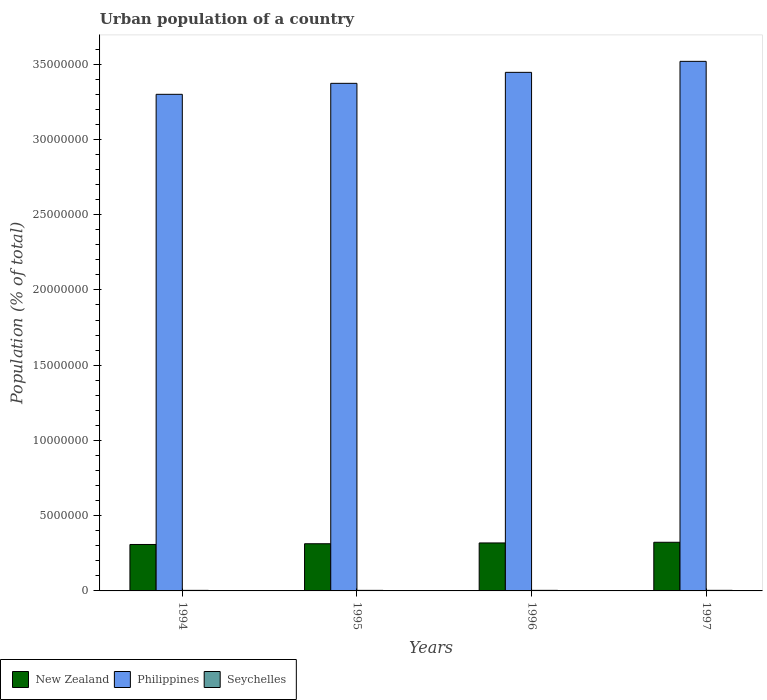How many different coloured bars are there?
Offer a terse response. 3. How many groups of bars are there?
Your answer should be very brief. 4. Are the number of bars per tick equal to the number of legend labels?
Ensure brevity in your answer.  Yes. How many bars are there on the 1st tick from the left?
Make the answer very short. 3. How many bars are there on the 2nd tick from the right?
Make the answer very short. 3. What is the label of the 2nd group of bars from the left?
Offer a very short reply. 1995. What is the urban population in Philippines in 1995?
Offer a terse response. 3.37e+07. Across all years, what is the maximum urban population in Seychelles?
Provide a short and direct response. 3.84e+04. Across all years, what is the minimum urban population in Seychelles?
Your answer should be very brief. 3.65e+04. In which year was the urban population in Philippines maximum?
Offer a terse response. 1997. What is the total urban population in Seychelles in the graph?
Your answer should be very brief. 1.50e+05. What is the difference between the urban population in Philippines in 1994 and that in 1995?
Make the answer very short. -7.30e+05. What is the difference between the urban population in Seychelles in 1997 and the urban population in New Zealand in 1996?
Your answer should be compact. -3.15e+06. What is the average urban population in New Zealand per year?
Provide a succinct answer. 3.16e+06. In the year 1997, what is the difference between the urban population in New Zealand and urban population in Philippines?
Provide a succinct answer. -3.20e+07. What is the ratio of the urban population in Philippines in 1996 to that in 1997?
Ensure brevity in your answer.  0.98. Is the difference between the urban population in New Zealand in 1995 and 1996 greater than the difference between the urban population in Philippines in 1995 and 1996?
Provide a short and direct response. Yes. What is the difference between the highest and the second highest urban population in Seychelles?
Your answer should be compact. 530. What is the difference between the highest and the lowest urban population in Philippines?
Your answer should be very brief. 2.19e+06. Is the sum of the urban population in Philippines in 1996 and 1997 greater than the maximum urban population in New Zealand across all years?
Keep it short and to the point. Yes. What does the 2nd bar from the left in 1996 represents?
Make the answer very short. Philippines. What does the 1st bar from the right in 1996 represents?
Offer a very short reply. Seychelles. Are the values on the major ticks of Y-axis written in scientific E-notation?
Offer a terse response. No. How many legend labels are there?
Keep it short and to the point. 3. How are the legend labels stacked?
Ensure brevity in your answer.  Horizontal. What is the title of the graph?
Keep it short and to the point. Urban population of a country. Does "Ireland" appear as one of the legend labels in the graph?
Your response must be concise. No. What is the label or title of the Y-axis?
Provide a succinct answer. Population (% of total). What is the Population (% of total) in New Zealand in 1994?
Make the answer very short. 3.09e+06. What is the Population (% of total) in Philippines in 1994?
Your answer should be compact. 3.30e+07. What is the Population (% of total) in Seychelles in 1994?
Your answer should be very brief. 3.65e+04. What is the Population (% of total) of New Zealand in 1995?
Your response must be concise. 3.13e+06. What is the Population (% of total) in Philippines in 1995?
Keep it short and to the point. 3.37e+07. What is the Population (% of total) in Seychelles in 1995?
Your answer should be very brief. 3.73e+04. What is the Population (% of total) of New Zealand in 1996?
Offer a terse response. 3.19e+06. What is the Population (% of total) of Philippines in 1996?
Give a very brief answer. 3.45e+07. What is the Population (% of total) of Seychelles in 1996?
Give a very brief answer. 3.79e+04. What is the Population (% of total) in New Zealand in 1997?
Your response must be concise. 3.23e+06. What is the Population (% of total) of Philippines in 1997?
Your answer should be very brief. 3.52e+07. What is the Population (% of total) in Seychelles in 1997?
Your response must be concise. 3.84e+04. Across all years, what is the maximum Population (% of total) of New Zealand?
Your answer should be compact. 3.23e+06. Across all years, what is the maximum Population (% of total) in Philippines?
Give a very brief answer. 3.52e+07. Across all years, what is the maximum Population (% of total) in Seychelles?
Make the answer very short. 3.84e+04. Across all years, what is the minimum Population (% of total) of New Zealand?
Provide a short and direct response. 3.09e+06. Across all years, what is the minimum Population (% of total) of Philippines?
Ensure brevity in your answer.  3.30e+07. Across all years, what is the minimum Population (% of total) of Seychelles?
Provide a succinct answer. 3.65e+04. What is the total Population (% of total) of New Zealand in the graph?
Make the answer very short. 1.26e+07. What is the total Population (% of total) of Philippines in the graph?
Keep it short and to the point. 1.36e+08. What is the total Population (% of total) in Seychelles in the graph?
Your response must be concise. 1.50e+05. What is the difference between the Population (% of total) in New Zealand in 1994 and that in 1995?
Provide a short and direct response. -4.92e+04. What is the difference between the Population (% of total) of Philippines in 1994 and that in 1995?
Provide a succinct answer. -7.30e+05. What is the difference between the Population (% of total) in Seychelles in 1994 and that in 1995?
Ensure brevity in your answer.  -742. What is the difference between the Population (% of total) of New Zealand in 1994 and that in 1996?
Offer a very short reply. -1.02e+05. What is the difference between the Population (% of total) of Philippines in 1994 and that in 1996?
Keep it short and to the point. -1.46e+06. What is the difference between the Population (% of total) of Seychelles in 1994 and that in 1996?
Your answer should be very brief. -1364. What is the difference between the Population (% of total) in New Zealand in 1994 and that in 1997?
Your answer should be very brief. -1.47e+05. What is the difference between the Population (% of total) of Philippines in 1994 and that in 1997?
Provide a short and direct response. -2.19e+06. What is the difference between the Population (% of total) in Seychelles in 1994 and that in 1997?
Ensure brevity in your answer.  -1894. What is the difference between the Population (% of total) of New Zealand in 1995 and that in 1996?
Provide a succinct answer. -5.33e+04. What is the difference between the Population (% of total) in Philippines in 1995 and that in 1996?
Make the answer very short. -7.31e+05. What is the difference between the Population (% of total) of Seychelles in 1995 and that in 1996?
Your response must be concise. -622. What is the difference between the Population (% of total) in New Zealand in 1995 and that in 1997?
Your answer should be compact. -9.78e+04. What is the difference between the Population (% of total) in Philippines in 1995 and that in 1997?
Your answer should be very brief. -1.46e+06. What is the difference between the Population (% of total) in Seychelles in 1995 and that in 1997?
Your response must be concise. -1152. What is the difference between the Population (% of total) in New Zealand in 1996 and that in 1997?
Ensure brevity in your answer.  -4.45e+04. What is the difference between the Population (% of total) in Philippines in 1996 and that in 1997?
Give a very brief answer. -7.30e+05. What is the difference between the Population (% of total) in Seychelles in 1996 and that in 1997?
Provide a short and direct response. -530. What is the difference between the Population (% of total) in New Zealand in 1994 and the Population (% of total) in Philippines in 1995?
Offer a terse response. -3.06e+07. What is the difference between the Population (% of total) in New Zealand in 1994 and the Population (% of total) in Seychelles in 1995?
Offer a very short reply. 3.05e+06. What is the difference between the Population (% of total) in Philippines in 1994 and the Population (% of total) in Seychelles in 1995?
Your answer should be very brief. 3.30e+07. What is the difference between the Population (% of total) in New Zealand in 1994 and the Population (% of total) in Philippines in 1996?
Offer a terse response. -3.14e+07. What is the difference between the Population (% of total) in New Zealand in 1994 and the Population (% of total) in Seychelles in 1996?
Provide a short and direct response. 3.05e+06. What is the difference between the Population (% of total) in Philippines in 1994 and the Population (% of total) in Seychelles in 1996?
Your answer should be compact. 3.30e+07. What is the difference between the Population (% of total) in New Zealand in 1994 and the Population (% of total) in Philippines in 1997?
Offer a very short reply. -3.21e+07. What is the difference between the Population (% of total) of New Zealand in 1994 and the Population (% of total) of Seychelles in 1997?
Provide a succinct answer. 3.05e+06. What is the difference between the Population (% of total) of Philippines in 1994 and the Population (% of total) of Seychelles in 1997?
Make the answer very short. 3.30e+07. What is the difference between the Population (% of total) in New Zealand in 1995 and the Population (% of total) in Philippines in 1996?
Your answer should be very brief. -3.13e+07. What is the difference between the Population (% of total) in New Zealand in 1995 and the Population (% of total) in Seychelles in 1996?
Make the answer very short. 3.10e+06. What is the difference between the Population (% of total) in Philippines in 1995 and the Population (% of total) in Seychelles in 1996?
Provide a succinct answer. 3.37e+07. What is the difference between the Population (% of total) of New Zealand in 1995 and the Population (% of total) of Philippines in 1997?
Give a very brief answer. -3.21e+07. What is the difference between the Population (% of total) of New Zealand in 1995 and the Population (% of total) of Seychelles in 1997?
Provide a short and direct response. 3.10e+06. What is the difference between the Population (% of total) in Philippines in 1995 and the Population (% of total) in Seychelles in 1997?
Offer a terse response. 3.37e+07. What is the difference between the Population (% of total) in New Zealand in 1996 and the Population (% of total) in Philippines in 1997?
Provide a short and direct response. -3.20e+07. What is the difference between the Population (% of total) of New Zealand in 1996 and the Population (% of total) of Seychelles in 1997?
Provide a short and direct response. 3.15e+06. What is the difference between the Population (% of total) in Philippines in 1996 and the Population (% of total) in Seychelles in 1997?
Keep it short and to the point. 3.44e+07. What is the average Population (% of total) in New Zealand per year?
Ensure brevity in your answer.  3.16e+06. What is the average Population (% of total) of Philippines per year?
Your response must be concise. 3.41e+07. What is the average Population (% of total) in Seychelles per year?
Give a very brief answer. 3.75e+04. In the year 1994, what is the difference between the Population (% of total) of New Zealand and Population (% of total) of Philippines?
Provide a succinct answer. -2.99e+07. In the year 1994, what is the difference between the Population (% of total) of New Zealand and Population (% of total) of Seychelles?
Offer a very short reply. 3.05e+06. In the year 1994, what is the difference between the Population (% of total) in Philippines and Population (% of total) in Seychelles?
Your answer should be compact. 3.30e+07. In the year 1995, what is the difference between the Population (% of total) in New Zealand and Population (% of total) in Philippines?
Give a very brief answer. -3.06e+07. In the year 1995, what is the difference between the Population (% of total) in New Zealand and Population (% of total) in Seychelles?
Offer a very short reply. 3.10e+06. In the year 1995, what is the difference between the Population (% of total) of Philippines and Population (% of total) of Seychelles?
Offer a terse response. 3.37e+07. In the year 1996, what is the difference between the Population (% of total) of New Zealand and Population (% of total) of Philippines?
Offer a very short reply. -3.13e+07. In the year 1996, what is the difference between the Population (% of total) in New Zealand and Population (% of total) in Seychelles?
Your answer should be very brief. 3.15e+06. In the year 1996, what is the difference between the Population (% of total) in Philippines and Population (% of total) in Seychelles?
Keep it short and to the point. 3.44e+07. In the year 1997, what is the difference between the Population (% of total) of New Zealand and Population (% of total) of Philippines?
Ensure brevity in your answer.  -3.20e+07. In the year 1997, what is the difference between the Population (% of total) of New Zealand and Population (% of total) of Seychelles?
Provide a short and direct response. 3.19e+06. In the year 1997, what is the difference between the Population (% of total) in Philippines and Population (% of total) in Seychelles?
Your response must be concise. 3.51e+07. What is the ratio of the Population (% of total) in New Zealand in 1994 to that in 1995?
Ensure brevity in your answer.  0.98. What is the ratio of the Population (% of total) in Philippines in 1994 to that in 1995?
Make the answer very short. 0.98. What is the ratio of the Population (% of total) of Seychelles in 1994 to that in 1995?
Your answer should be very brief. 0.98. What is the ratio of the Population (% of total) of New Zealand in 1994 to that in 1996?
Ensure brevity in your answer.  0.97. What is the ratio of the Population (% of total) in Philippines in 1994 to that in 1996?
Provide a succinct answer. 0.96. What is the ratio of the Population (% of total) of New Zealand in 1994 to that in 1997?
Your response must be concise. 0.95. What is the ratio of the Population (% of total) of Philippines in 1994 to that in 1997?
Offer a terse response. 0.94. What is the ratio of the Population (% of total) in Seychelles in 1994 to that in 1997?
Keep it short and to the point. 0.95. What is the ratio of the Population (% of total) of New Zealand in 1995 to that in 1996?
Offer a very short reply. 0.98. What is the ratio of the Population (% of total) in Philippines in 1995 to that in 1996?
Your answer should be very brief. 0.98. What is the ratio of the Population (% of total) in Seychelles in 1995 to that in 1996?
Provide a short and direct response. 0.98. What is the ratio of the Population (% of total) of New Zealand in 1995 to that in 1997?
Make the answer very short. 0.97. What is the ratio of the Population (% of total) of Philippines in 1995 to that in 1997?
Keep it short and to the point. 0.96. What is the ratio of the Population (% of total) of Seychelles in 1995 to that in 1997?
Your answer should be compact. 0.97. What is the ratio of the Population (% of total) of New Zealand in 1996 to that in 1997?
Your response must be concise. 0.99. What is the ratio of the Population (% of total) in Philippines in 1996 to that in 1997?
Provide a short and direct response. 0.98. What is the ratio of the Population (% of total) of Seychelles in 1996 to that in 1997?
Give a very brief answer. 0.99. What is the difference between the highest and the second highest Population (% of total) of New Zealand?
Your answer should be compact. 4.45e+04. What is the difference between the highest and the second highest Population (% of total) in Philippines?
Your answer should be compact. 7.30e+05. What is the difference between the highest and the second highest Population (% of total) of Seychelles?
Your answer should be compact. 530. What is the difference between the highest and the lowest Population (% of total) of New Zealand?
Make the answer very short. 1.47e+05. What is the difference between the highest and the lowest Population (% of total) in Philippines?
Make the answer very short. 2.19e+06. What is the difference between the highest and the lowest Population (% of total) in Seychelles?
Make the answer very short. 1894. 